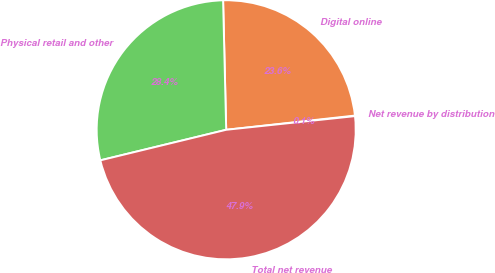<chart> <loc_0><loc_0><loc_500><loc_500><pie_chart><fcel>Net revenue by distribution<fcel>Digital online<fcel>Physical retail and other<fcel>Total net revenue<nl><fcel>0.07%<fcel>23.63%<fcel>28.41%<fcel>47.89%<nl></chart> 